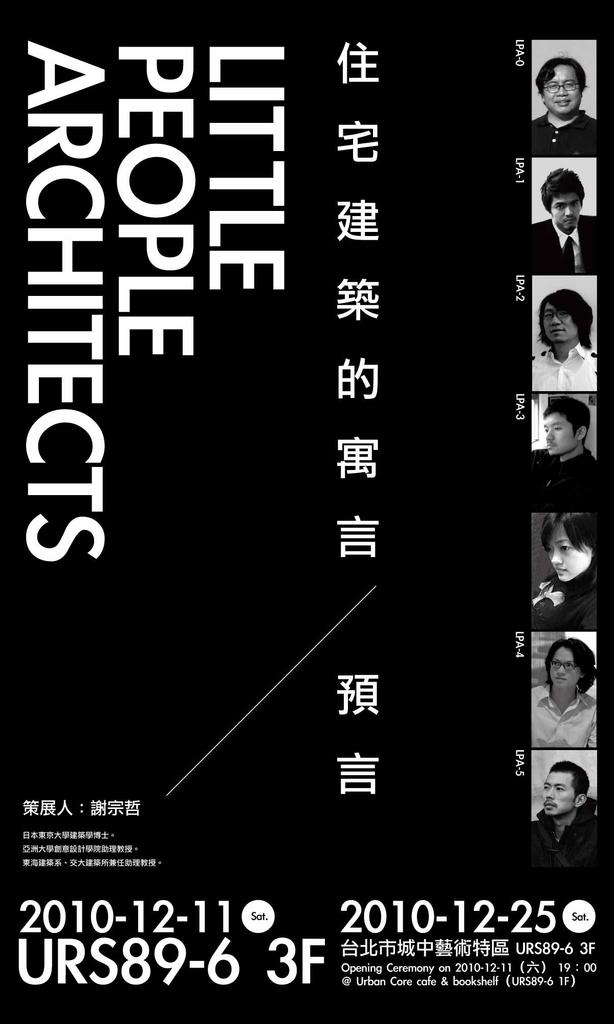<image>
Share a concise interpretation of the image provided. An advertisement mostly in Chinese called little people architects 